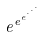<formula> <loc_0><loc_0><loc_500><loc_500>e ^ { e ^ { e ^ { \cdot ^ { \cdot ^ { \cdot } } } } }</formula> 